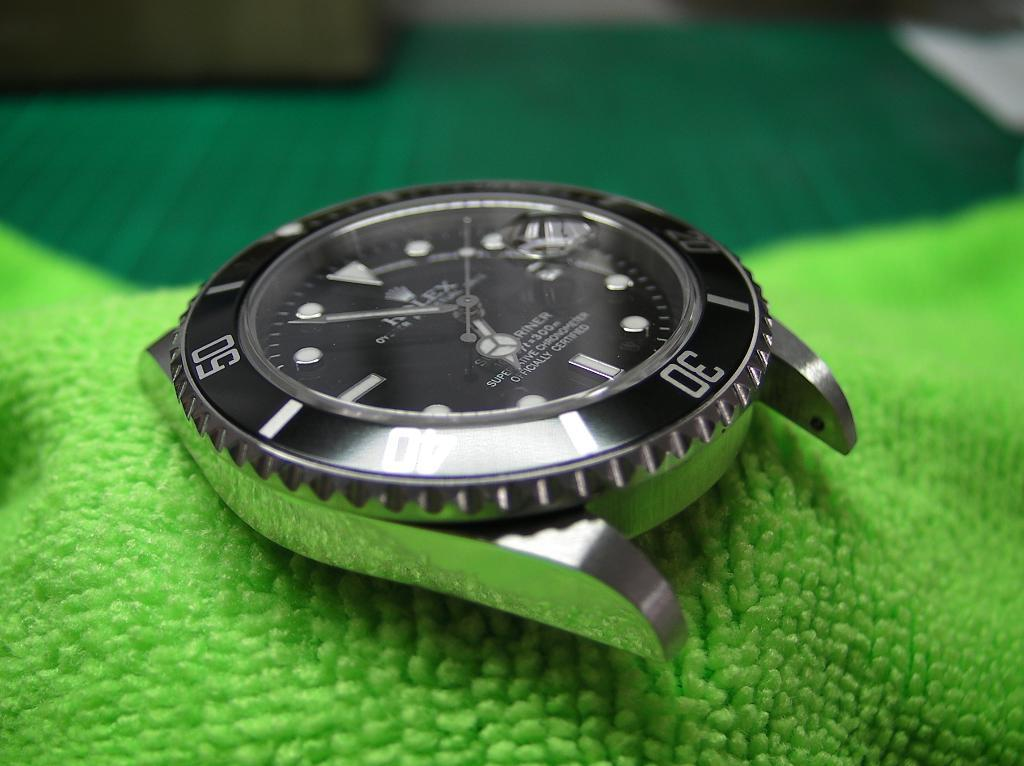<image>
Render a clear and concise summary of the photo. The main piece of a Rolex wrist watch is laying on a green, micro fiber cloth. 